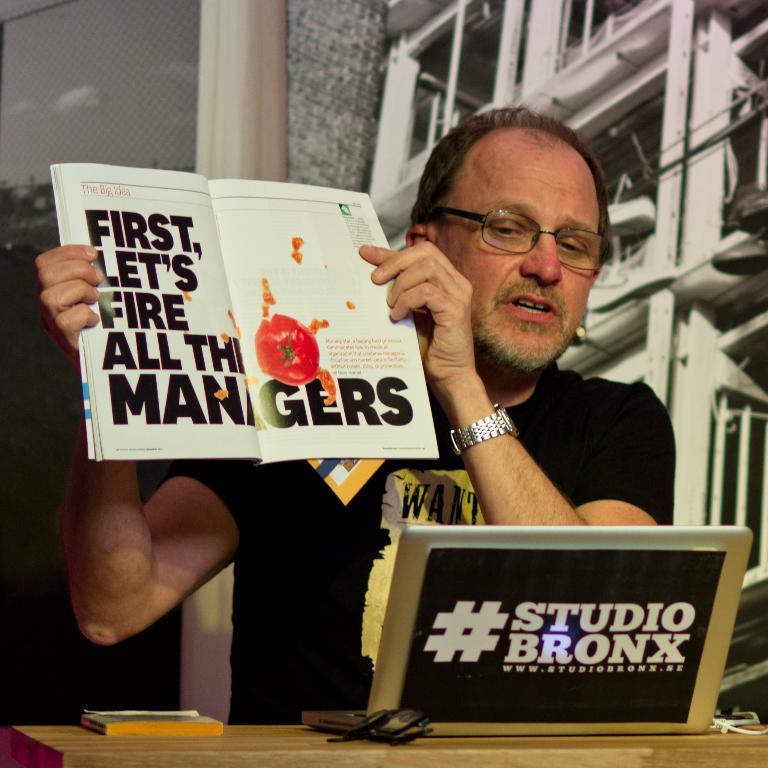Describe this image in one or two sentences. In this picture we can see a man wore spectacles, watch and holding a book with his hand and in front of him we can see a laptop, book, spectacles on a wooden surface and in the background we can see some objects. 